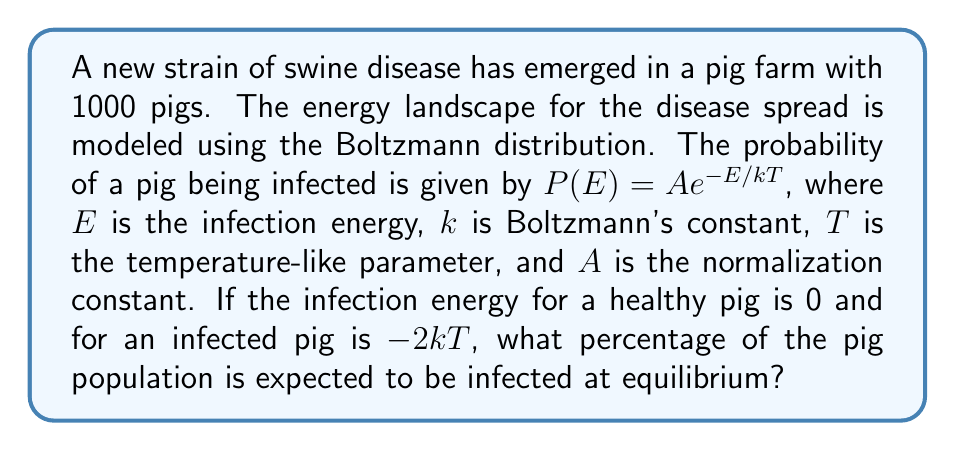Give your solution to this math problem. To solve this problem, we'll follow these steps:

1) The Boltzmann distribution gives the probability of a system being in a state with energy E:

   $P(E) = A e^{-E/kT}$

2) We have two states: healthy (E = 0) and infected (E = -2kT)

3) For the healthy state:
   $P(healthy) = A e^{-0/kT} = A$

4) For the infected state:
   $P(infected) = A e^{-(-2kT)/kT} = A e^2$

5) The sum of probabilities must equal 1:
   $P(healthy) + P(infected) = 1$
   $A + A e^2 = 1$

6) Solve for A:
   $A(1 + e^2) = 1$
   $A = \frac{1}{1 + e^2}$

7) The probability of a pig being infected is:
   $P(infected) = A e^2 = \frac{e^2}{1 + e^2}$

8) Convert to percentage:
   $Percentage = \frac{e^2}{1 + e^2} * 100\%$

9) Calculate:
   $\frac{e^2}{1 + e^2} * 100\% \approx 88.08\%$

Therefore, approximately 88.08% of the pig population is expected to be infected at equilibrium.
Answer: 88.08% 